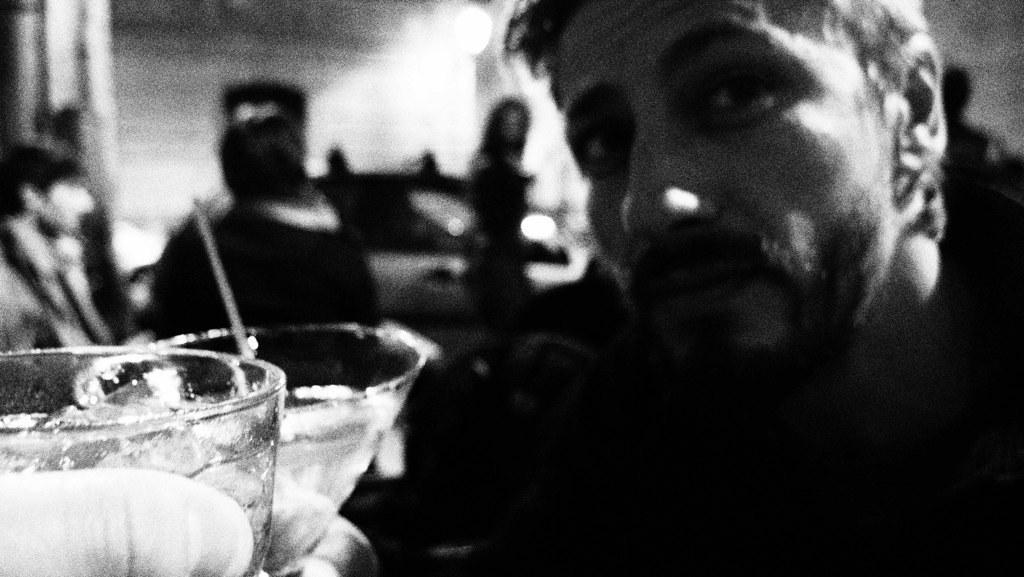How would you summarize this image in a sentence or two? On the left we can see two glasses. On the right we can see a person. On the left we can see a person's finger. The background is blurred. 